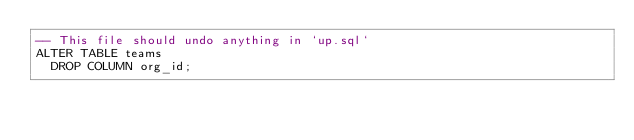<code> <loc_0><loc_0><loc_500><loc_500><_SQL_>-- This file should undo anything in `up.sql`
ALTER TABLE teams
  DROP COLUMN org_id;</code> 